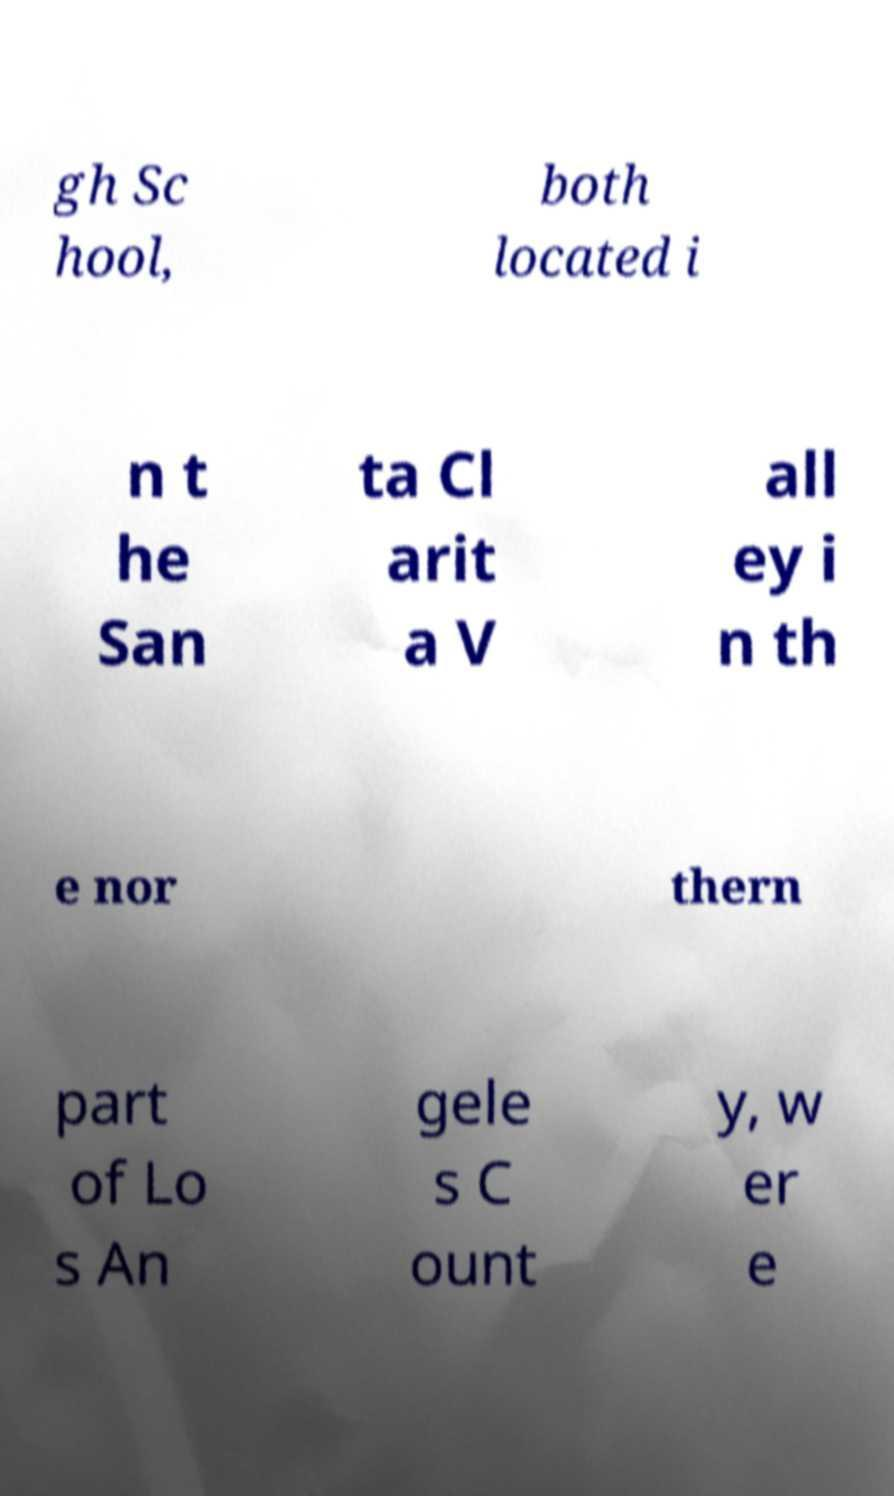Could you assist in decoding the text presented in this image and type it out clearly? gh Sc hool, both located i n t he San ta Cl arit a V all ey i n th e nor thern part of Lo s An gele s C ount y, w er e 